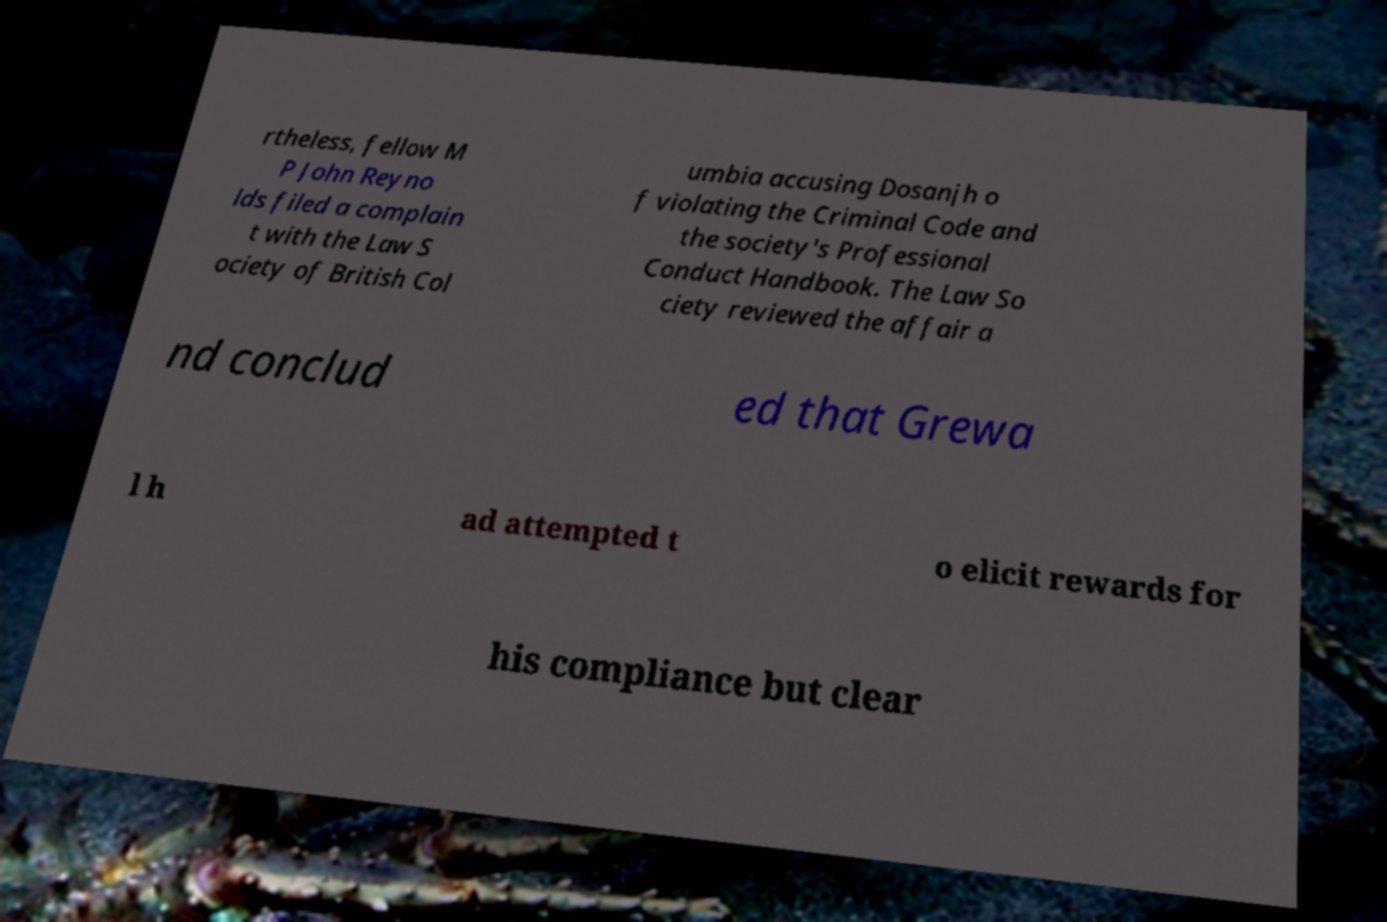What messages or text are displayed in this image? I need them in a readable, typed format. rtheless, fellow M P John Reyno lds filed a complain t with the Law S ociety of British Col umbia accusing Dosanjh o f violating the Criminal Code and the society's Professional Conduct Handbook. The Law So ciety reviewed the affair a nd conclud ed that Grewa l h ad attempted t o elicit rewards for his compliance but clear 